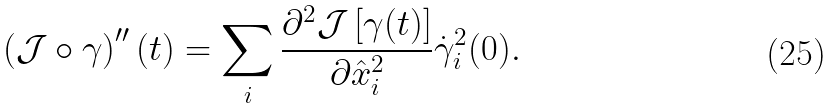Convert formula to latex. <formula><loc_0><loc_0><loc_500><loc_500>\left ( \mathcal { J } \circ \gamma \right ) ^ { \prime \prime } ( t ) = \sum _ { i } \frac { \partial ^ { 2 } \mathcal { J } \left [ \gamma ( t ) \right ] } { \partial \hat { x } _ { i } ^ { 2 } } \dot { \gamma } _ { i } ^ { 2 } ( 0 ) .</formula> 